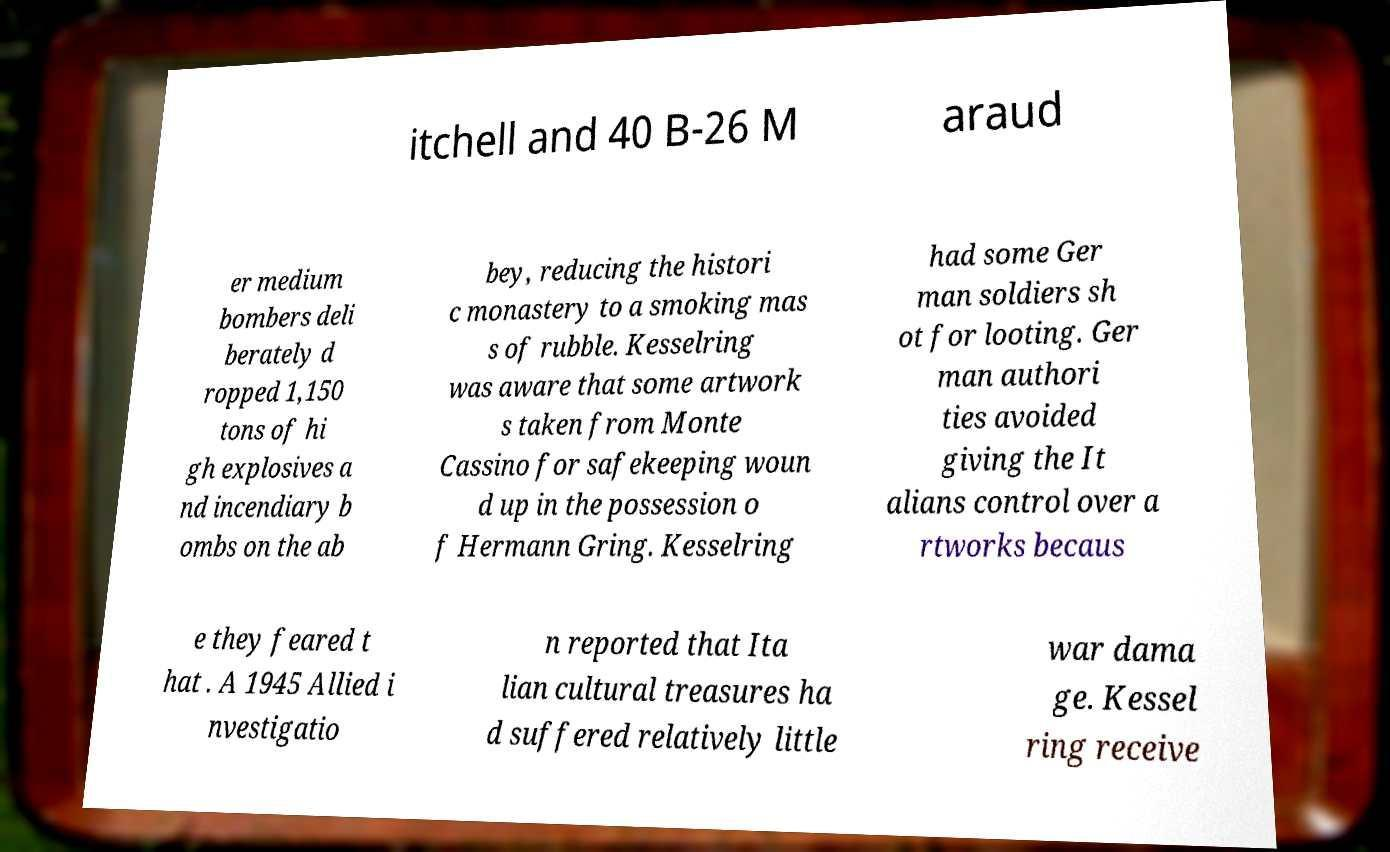Please read and relay the text visible in this image. What does it say? itchell and 40 B-26 M araud er medium bombers deli berately d ropped 1,150 tons of hi gh explosives a nd incendiary b ombs on the ab bey, reducing the histori c monastery to a smoking mas s of rubble. Kesselring was aware that some artwork s taken from Monte Cassino for safekeeping woun d up in the possession o f Hermann Gring. Kesselring had some Ger man soldiers sh ot for looting. Ger man authori ties avoided giving the It alians control over a rtworks becaus e they feared t hat . A 1945 Allied i nvestigatio n reported that Ita lian cultural treasures ha d suffered relatively little war dama ge. Kessel ring receive 